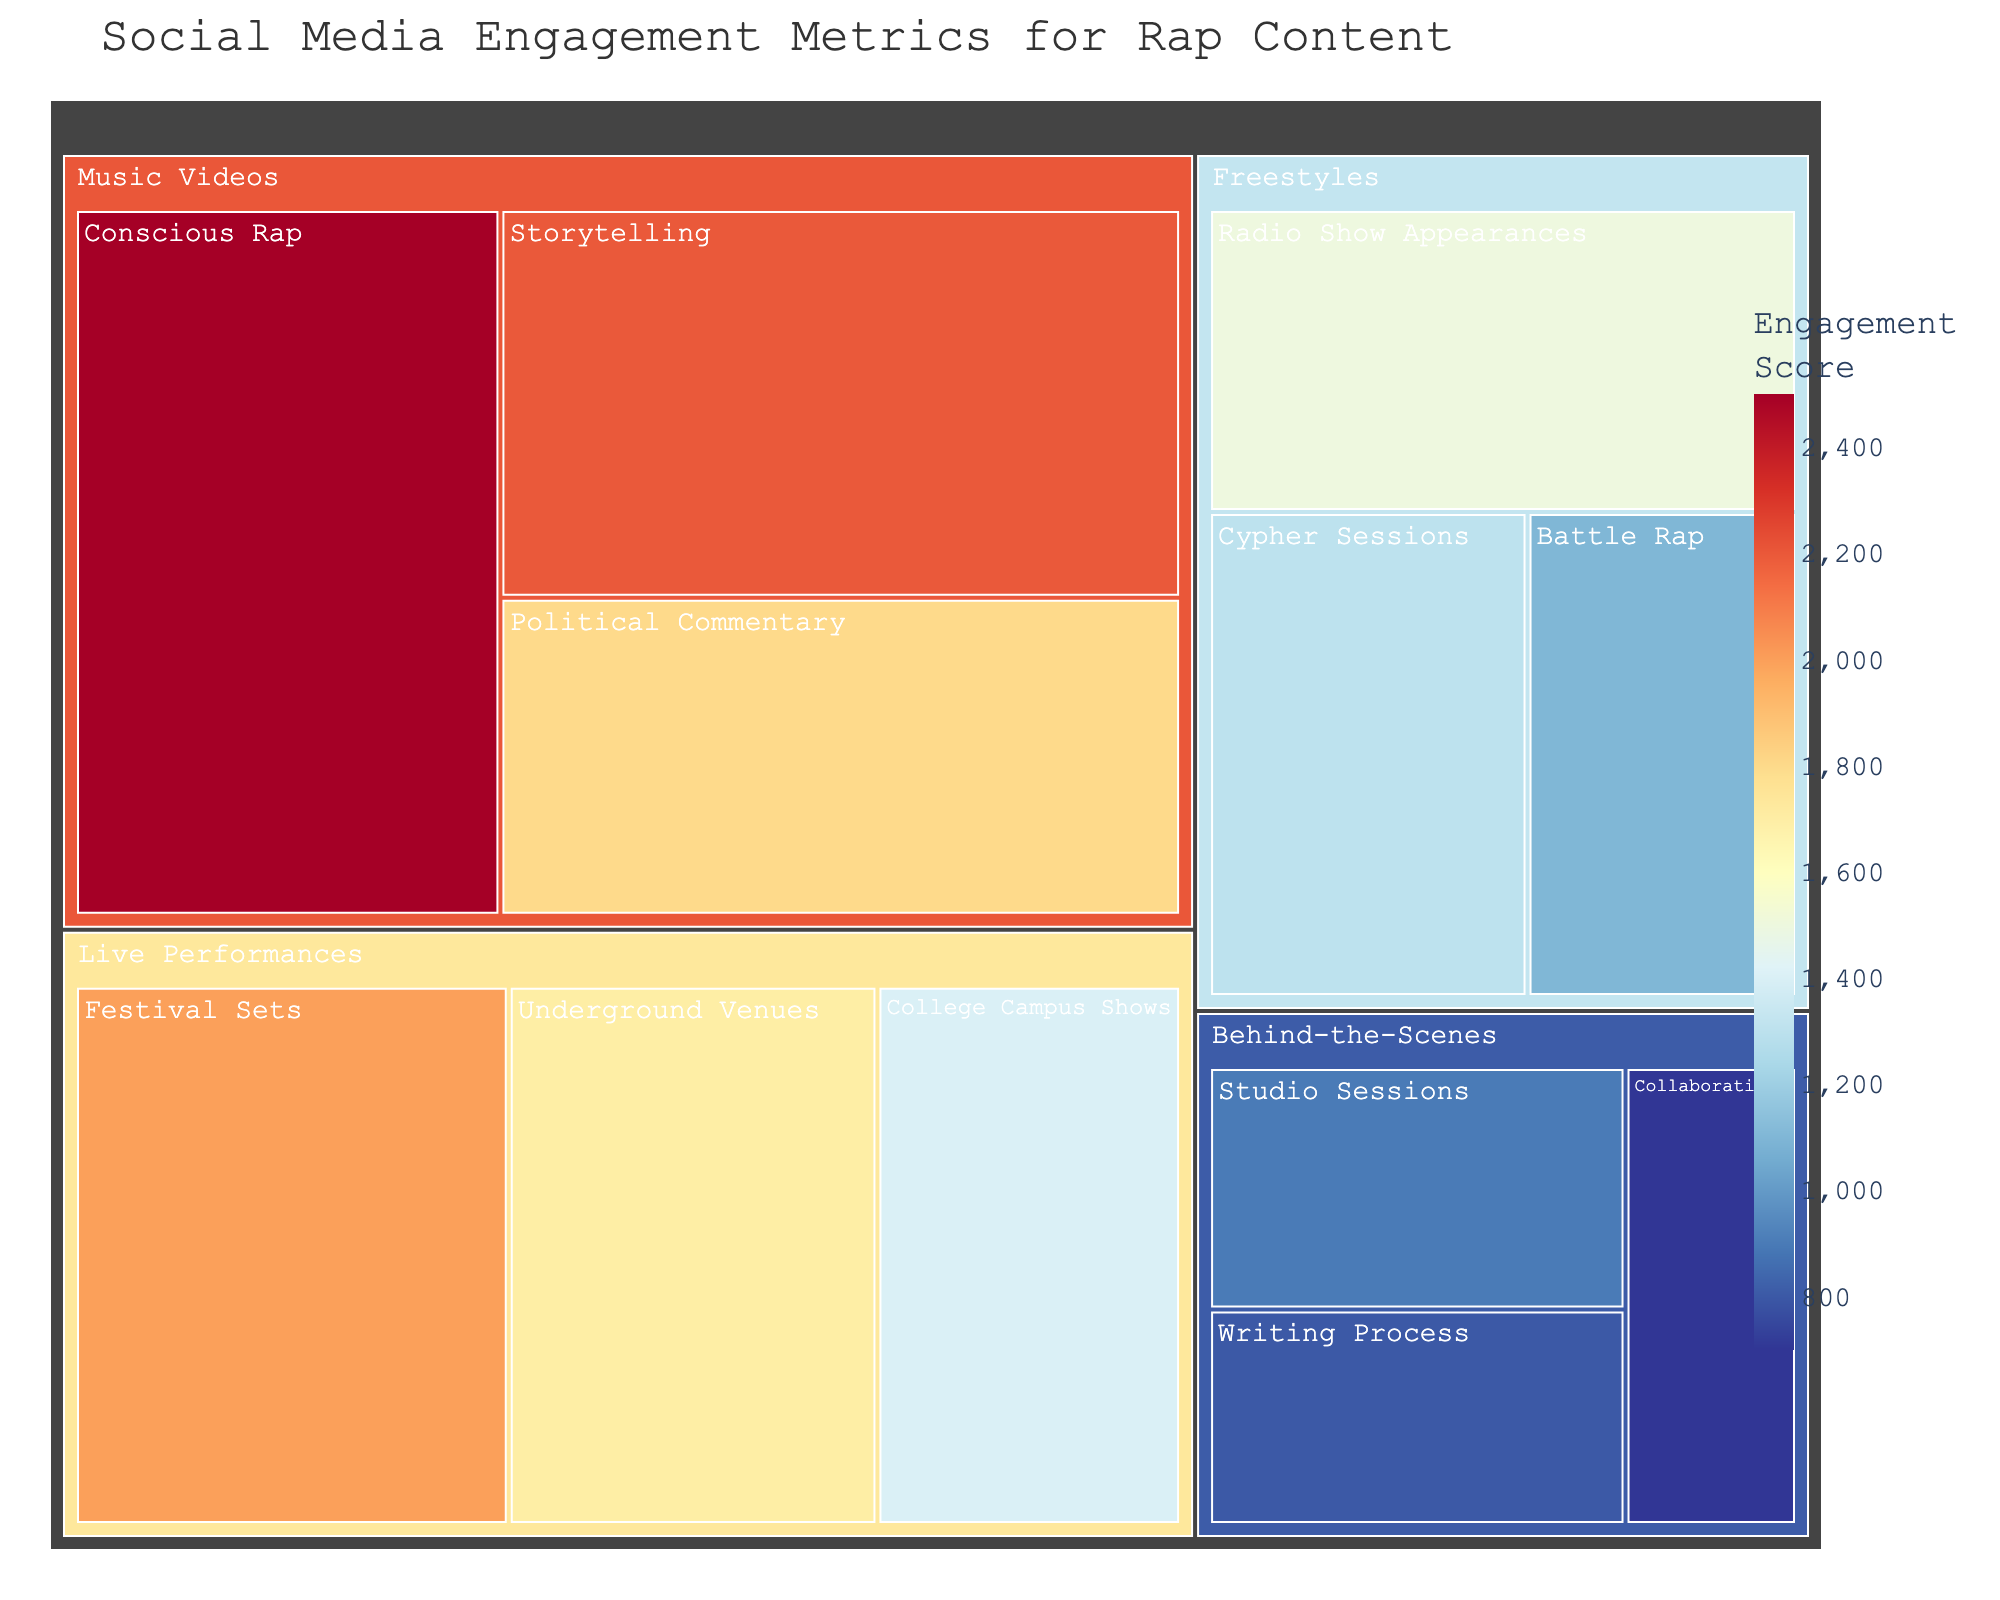What's the title of the plot? The title is usually placed at the top of the plot. It's written as clear text to describe what the treemap represents. In this figure, the title is "Social Media Engagement Metrics for Rap Content".
Answer: Social Media Engagement Metrics for Rap Content Which content type within Music Videos has the highest engagement score? Look within the Music Videos category on the plot. The different content types along with their scores are visually represented as boxes. The one with the highest score will have the largest area and the highest number.
Answer: Conscious Rap What’s the total engagement score for Freestyles? To find the total, locate each content type within the Freestyles category on the plot, and sum their engagement scores: (Radio Show Appearances: 1500) + (Cypher Sessions: 1300) + (Battle Rap: 1100). The sum gives the total engagement score for Freestyles.
Answer: 3900 Which category has the least engaged content type and what is it? Identify the category and content type with the smallest box, which corresponds to the lowest engagement score.
Answer: Behind-the-Scenes, Collaborations Comparing Festival Sets and Underground Venues under Live Performances, which has higher engagement, and by how much? Compare the engagement scores of Festival Sets and Underground Venues under the Live Performances category: (Festival Sets: 2000) and (Underground Venues: 1700). Calculate the difference: 2000 - 1700.
Answer: Festival Sets, by 300 What's the average engagement score for all content types under Behind-the-Scenes? Sum the engagement scores for all content types under Behind-the-Scenes and then divide by the number of content types. (Studio Sessions: 900) + (Writing Process: 800) + (Collaborations: 700) gives a total of 2400. There are 3 content types, so the average is 2400 / 3.
Answer: 800 How does the engagement score of Political Commentary in Music Videos compare to Battle Rap in Freestyles? Find the engagement scores for both content types: Political Commentary (1800), Battle Rap (1100). Then, compare them to see which one is higher and quantify the difference.
Answer: Political Commentary is higher by 700 What's the engagement score range for Live Performances category? Identify the highest and lowest engagement scores among content types within Live Performances. The highest is Festival Sets (2000) and the lowest is College Campus Shows (1400). Subtract the lowest from the highest to find the range: 2000 - 1400.
Answer: 600 Which category has the highest total engagement score and what is it? Sum the engagement scores of all content types within each category. Compare the totals to determine the highest. Music Videos: (2500 + 2200 + 1800 = 6500). Freestyles (3900). Live Performances (5100). Behind-the-Scenes (2400). Music Videos has the highest total.
Answer: Music Videos, 6500 